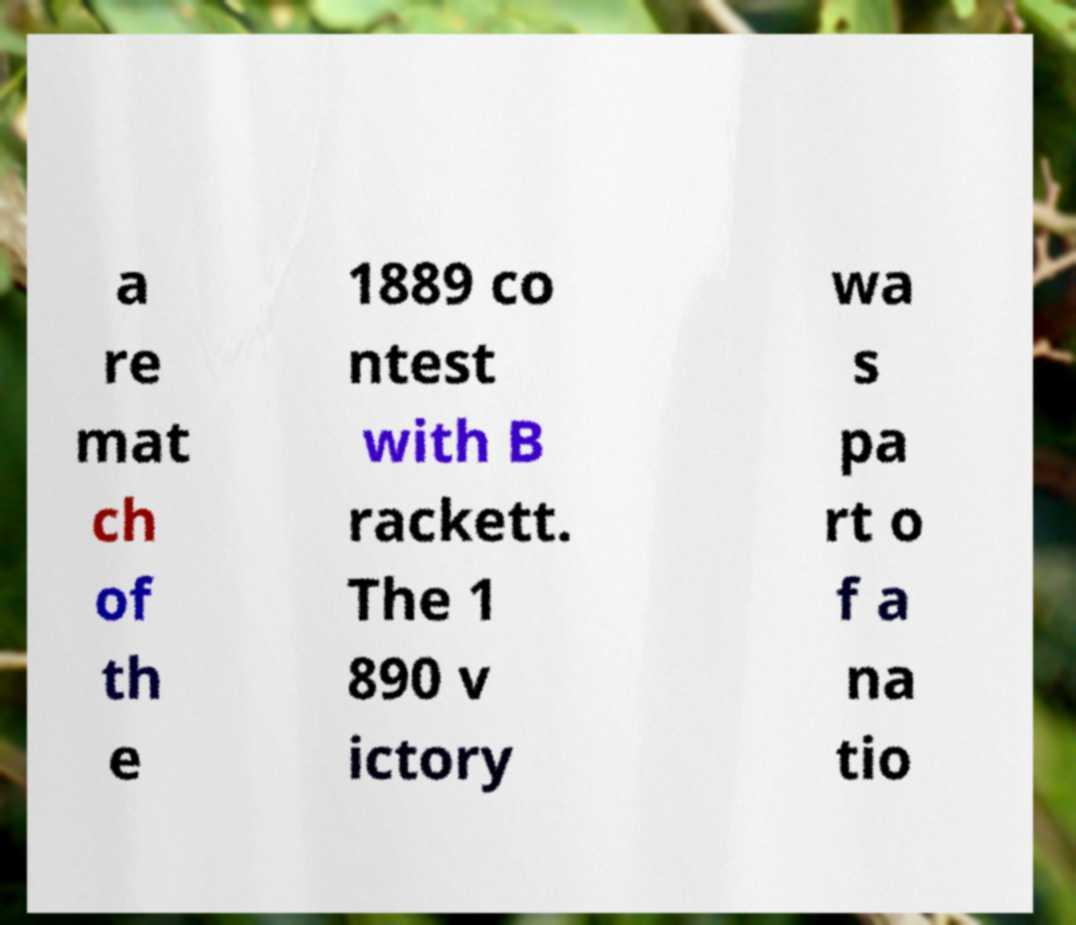Can you accurately transcribe the text from the provided image for me? a re mat ch of th e 1889 co ntest with B rackett. The 1 890 v ictory wa s pa rt o f a na tio 